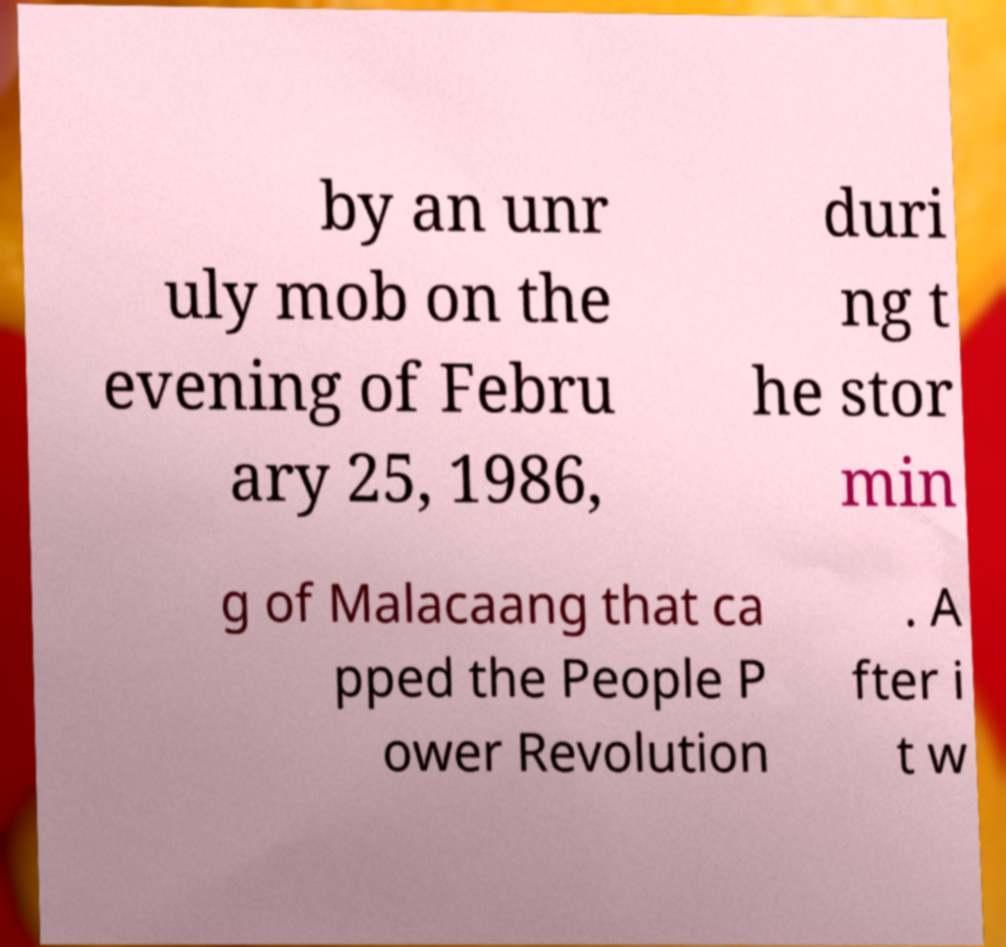Please identify and transcribe the text found in this image. by an unr uly mob on the evening of Febru ary 25, 1986, duri ng t he stor min g of Malacaang that ca pped the People P ower Revolution . A fter i t w 